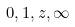<formula> <loc_0><loc_0><loc_500><loc_500>0 , 1 , z , \infty</formula> 